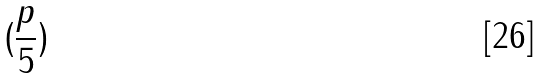<formula> <loc_0><loc_0><loc_500><loc_500>( \frac { p } { 5 } )</formula> 